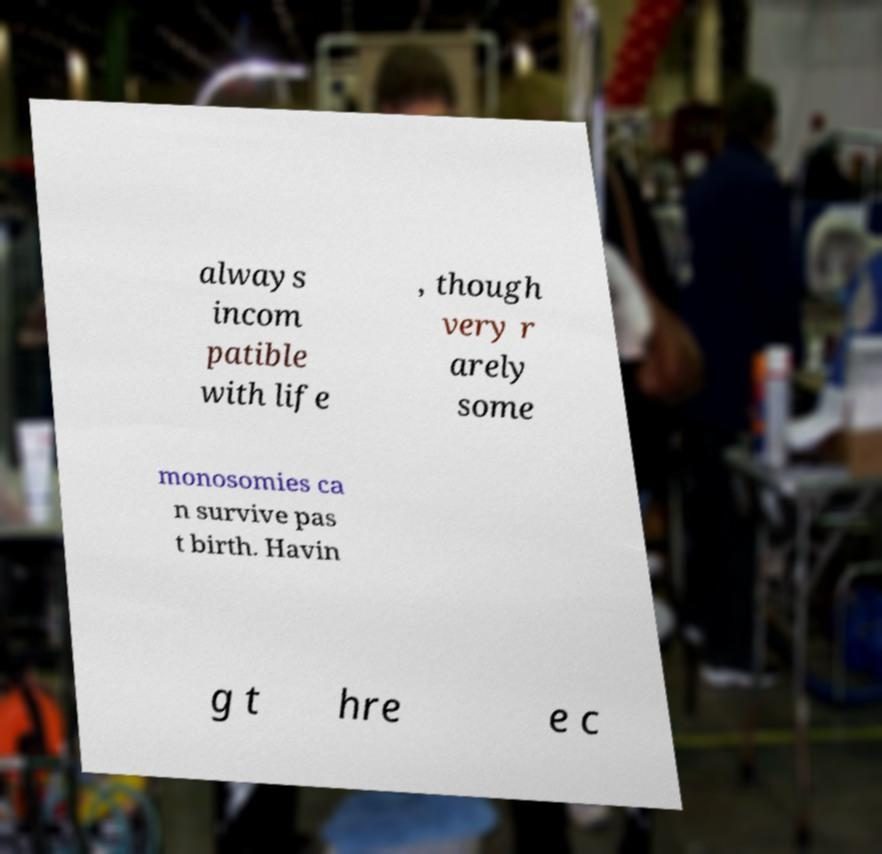Could you extract and type out the text from this image? always incom patible with life , though very r arely some monosomies ca n survive pas t birth. Havin g t hre e c 